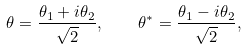<formula> <loc_0><loc_0><loc_500><loc_500>\theta = { \frac { \theta _ { 1 } + i \theta _ { 2 } } { \sqrt { 2 } } } , \quad \theta ^ { * } = { \frac { \theta _ { 1 } - i \theta _ { 2 } } { \sqrt { 2 } } } ,</formula> 